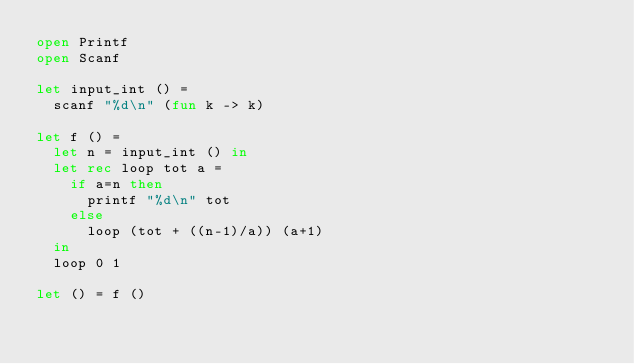<code> <loc_0><loc_0><loc_500><loc_500><_OCaml_>open Printf
open Scanf

let input_int () =
  scanf "%d\n" (fun k -> k)

let f () = 
  let n = input_int () in
  let rec loop tot a =
    if a=n then
      printf "%d\n" tot
    else
      loop (tot + ((n-1)/a)) (a+1)
  in
  loop 0 1

let () = f ()
</code> 